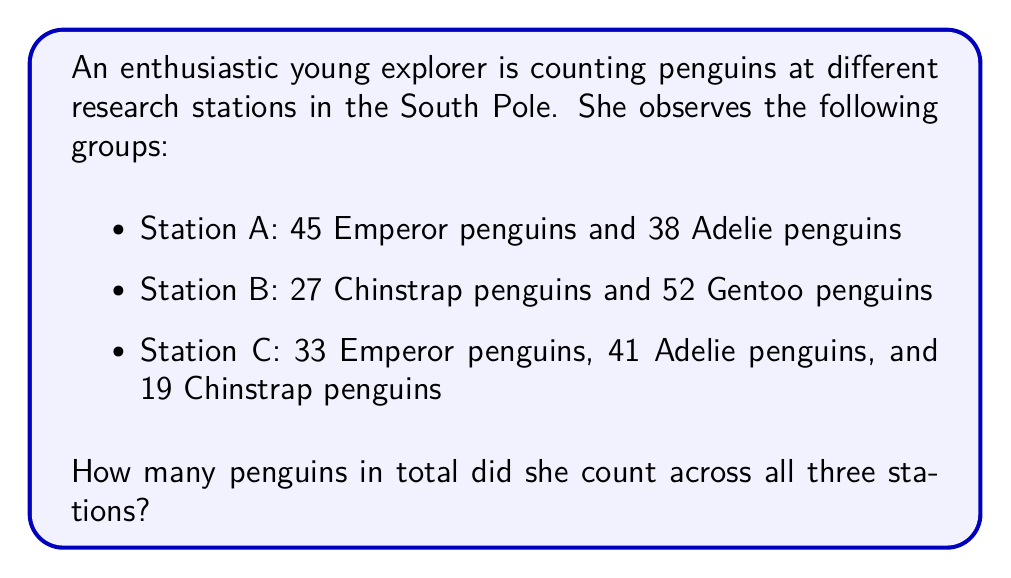What is the answer to this math problem? To solve this problem, we need to add up all the penguins from each station. Let's break it down step by step:

1. Count penguins at Station A:
   $45 + 38 = 83$ penguins

2. Count penguins at Station B:
   $27 + 52 = 79$ penguins

3. Count penguins at Station C:
   $33 + 41 + 19 = 93$ penguins

4. Sum up the total number of penguins from all stations:
   $$ \text{Total} = \text{Station A} + \text{Station B} + \text{Station C} $$
   $$ \text{Total} = 83 + 79 + 93 = 255 $$

Therefore, the young explorer counted a total of 255 penguins across all three stations.
Answer: 255 penguins 